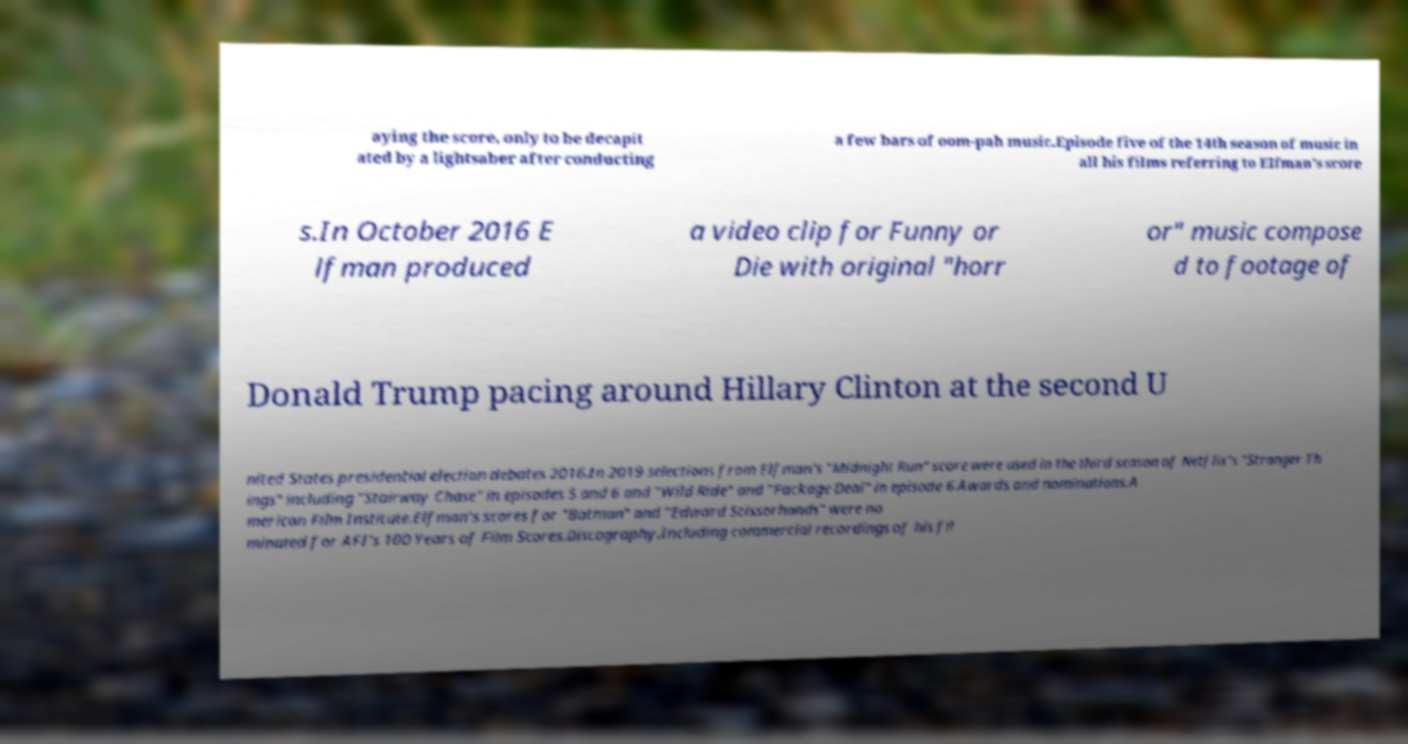I need the written content from this picture converted into text. Can you do that? aying the score, only to be decapit ated by a lightsaber after conducting a few bars of oom-pah music.Episode five of the 14th season of music in all his films referring to Elfman's score s.In October 2016 E lfman produced a video clip for Funny or Die with original "horr or" music compose d to footage of Donald Trump pacing around Hillary Clinton at the second U nited States presidential election debates 2016.In 2019 selections from Elfman's "Midnight Run" score were used in the third season of Netflix's "Stranger Th ings" including "Stairway Chase" in episodes 5 and 6 and "Wild Ride" and "Package Deal" in episode 6.Awards and nominations.A merican Film Institute.Elfman's scores for "Batman" and "Edward Scissorhands" were no minated for AFI's 100 Years of Film Scores.Discography.Including commercial recordings of his fil 